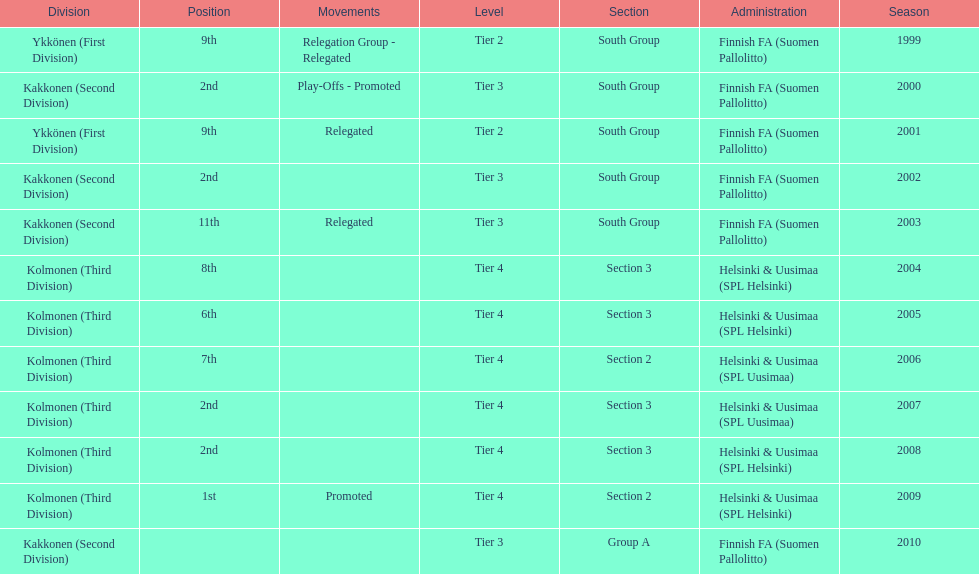How many times has this team been relegated? 3. 